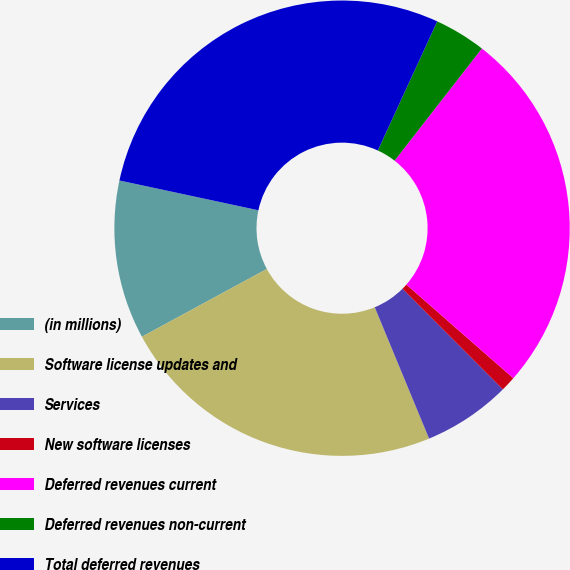<chart> <loc_0><loc_0><loc_500><loc_500><pie_chart><fcel>(in millions)<fcel>Software license updates and<fcel>Services<fcel>New software licenses<fcel>Deferred revenues current<fcel>Deferred revenues non-current<fcel>Total deferred revenues<nl><fcel>11.27%<fcel>23.33%<fcel>6.24%<fcel>1.07%<fcel>25.92%<fcel>3.66%<fcel>28.5%<nl></chart> 